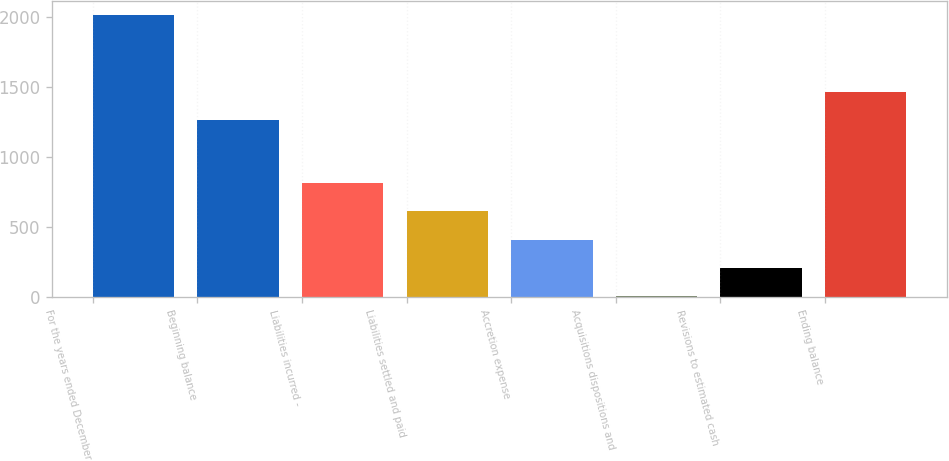Convert chart to OTSL. <chart><loc_0><loc_0><loc_500><loc_500><bar_chart><fcel>For the years ended December<fcel>Beginning balance<fcel>Liabilities incurred -<fcel>Liabilities settled and paid<fcel>Accretion expense<fcel>Acquisitions dispositions and<fcel>Revisions to estimated cash<fcel>Ending balance<nl><fcel>2013<fcel>1266<fcel>811.2<fcel>610.9<fcel>410.6<fcel>10<fcel>210.3<fcel>1466.3<nl></chart> 